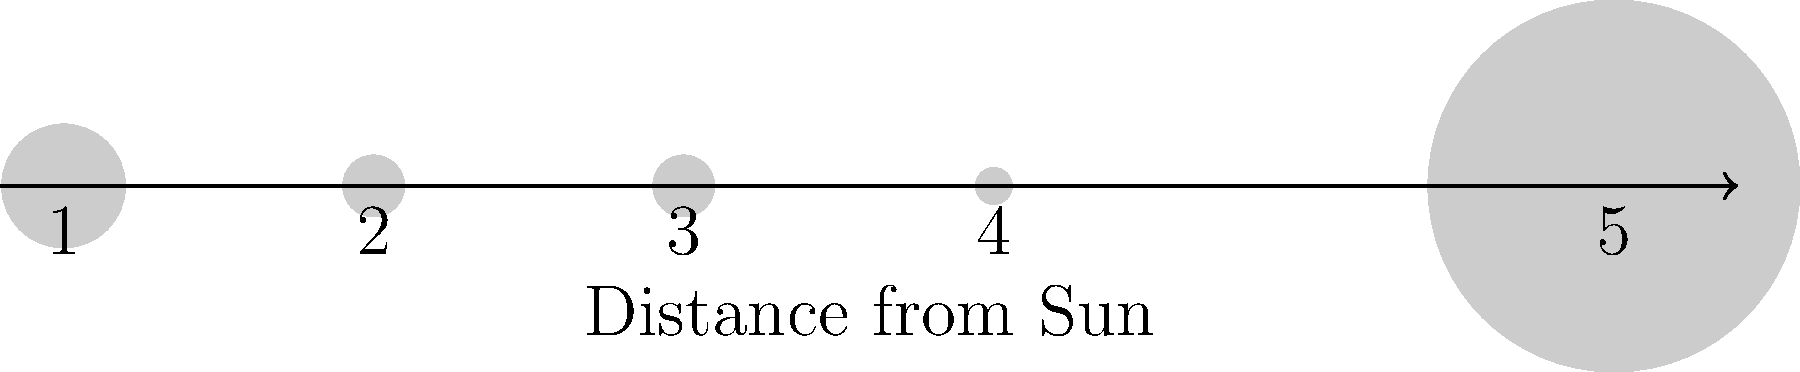As a fisherman accustomed to estimating the size and distance of fish in the river, consider the diagram showing five planets in our solar system (not to scale). If planet 1 represents the Sun, which planet most likely represents Jupiter, and why? To answer this question, we need to consider both the size and position of the planets in the diagram:

1. The Sun (planet 1) is the largest object in our solar system, represented by the largest circle in the diagram.

2. Jupiter is the largest planet in our solar system, so we're looking for the second-largest object in the diagram.

3. Jupiter is the 5th planet from the Sun, so its position should be relatively far from the Sun but not the farthest.

4. Looking at the diagram:
   - Planet 2 and 3 are the same size, smaller than the Sun
   - Planet 4 is the smallest
   - Planet 5 is the second-largest and positioned farther from the Sun

5. Given its size and position, planet 5 most likely represents Jupiter.

The relative sizes and distances in this diagram align with the characteristics of Jupiter in our solar system:
- It's the largest planet (represented by the second-largest circle)
- It's farther from the Sun than the inner planets but not as far as the outermost planets

This analysis is similar to how a fisherman might estimate the size and position of different fish species in a river based on their relative characteristics.
Answer: Planet 5 